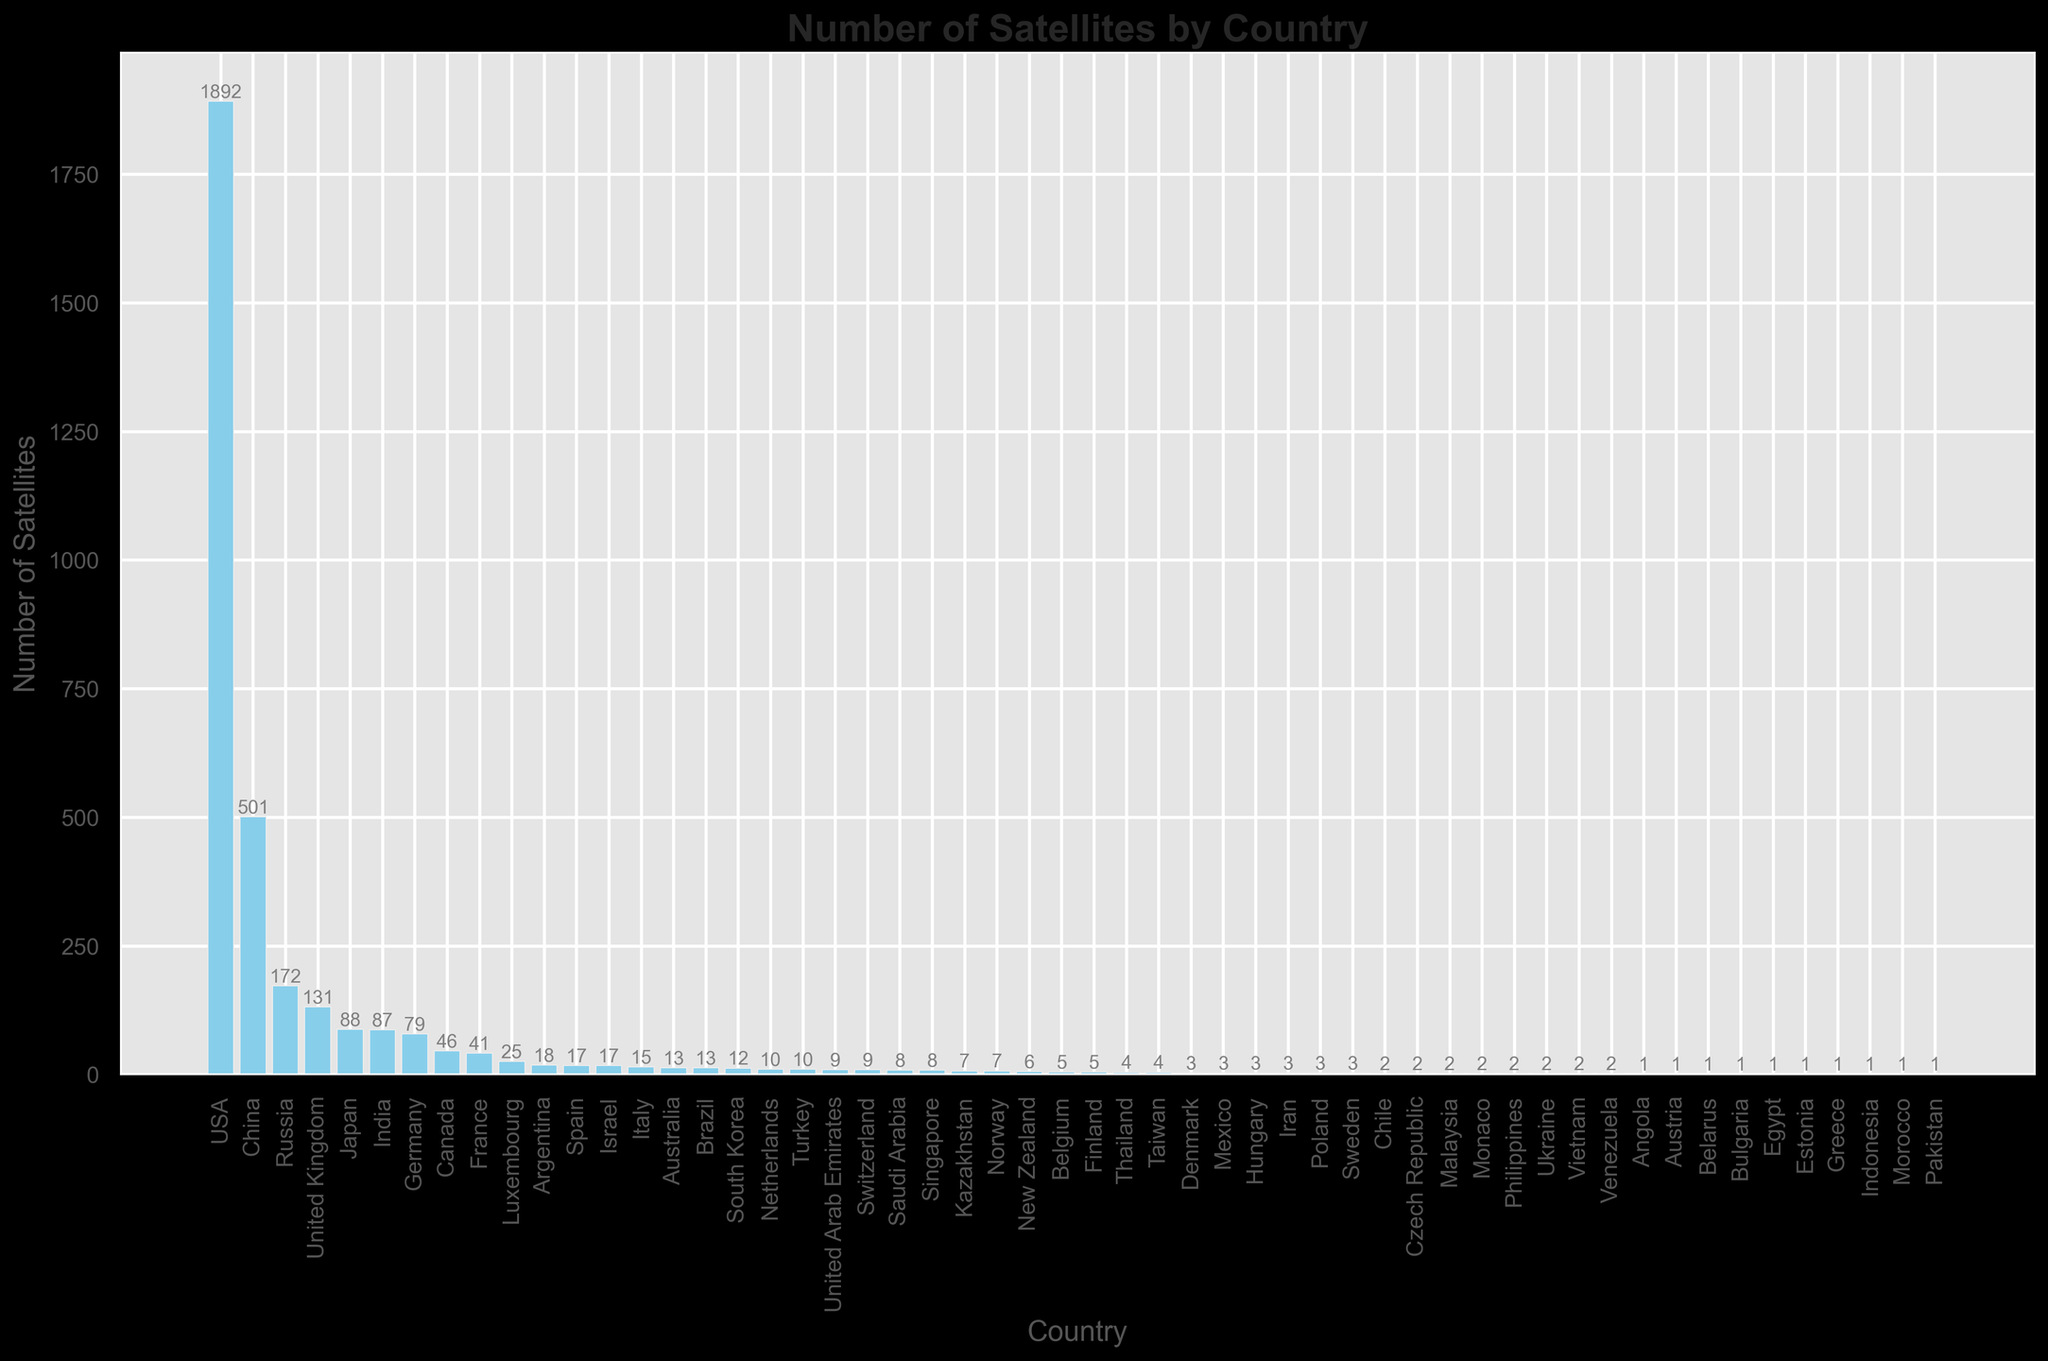Which country has the highest number of satellites? The highest bar on the histogram represents the USA with 1,892 satellites, which is the highest number among all countries listed.
Answer: USA How many more satellites does the USA have compared to China? The number of satellites for the USA is 1,892, and for China, it is 501. Subtracting the number of Chinese satellites from the number of American satellites gives 1,892 - 501 = 1,391.
Answer: 1,391 What is the total number of satellites launched by the top 3 countries? The top 3 countries are the USA, China, and Russia. Adding their respective satellite counts gives 1,892 + 501 + 172 = 2,565.
Answer: 2,565 Which countries have fewer than 10 satellites? The histogram shows several countries with fewer than 10 satellites, including but not limited to Norway, New Zealand, Belgium, Finland, Thailand, Taiwan, Denmark, Mexico, and Hungary.
Answer: Multiple (several countries) What is the combined number of satellites for Germany and France? Germany has 79 satellites and France has 41 satellites. Adding their numbers gives 79 + 41 = 120.
Answer: 120 Is the number of satellites from Japan greater than that from India? Japan has 88 satellites, and India has 87 satellites. Comparing the two, Japan has one more satellite than India.
Answer: Yes What is the average number of satellites among the countries that have launched more than 100 satellites? The countries with more than 100 satellites are the USA (1,892), China (501), Russia (172), and the United Kingdom (131). Adding these together gives 1,892 + 501 + 172 + 131 = 2,696. Dividing by 4 gives 2,696 / 4 = 674.
Answer: 674 Which country has just 1 satellite? Based on the histogram, the countries with only 1 satellite each are Angola, Austria, Belarus, Bulgaria, Egypt, Estonia, Greece, Indonesia, Morocco, and Pakistan.
Answer: Multiple (10 countries) How many satellites are there from countries that have exactly 2 satellites? The countries with exactly 2 satellites each are Chile, Czech Republic, Malaysia, Monaco, Philippines, Ukraine, Vietnam, and Venezuela. Summing their satellites gives 8 * 2 = 16.
Answer: 16 